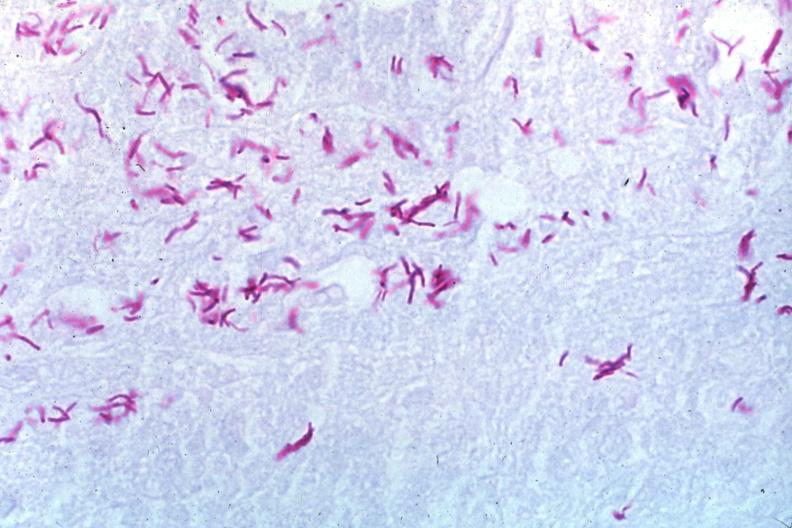what does this image show?
Answer the question using a single word or phrase. Oil acid fast stain a zillion organisms 